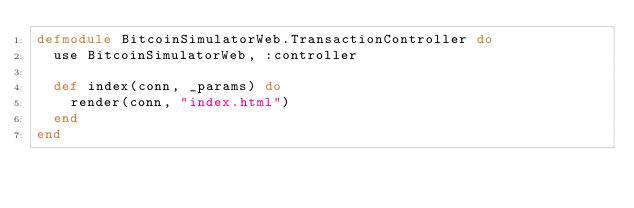Convert code to text. <code><loc_0><loc_0><loc_500><loc_500><_Elixir_>defmodule BitcoinSimulatorWeb.TransactionController do
  use BitcoinSimulatorWeb, :controller

  def index(conn, _params) do
    render(conn, "index.html")
  end
end
</code> 